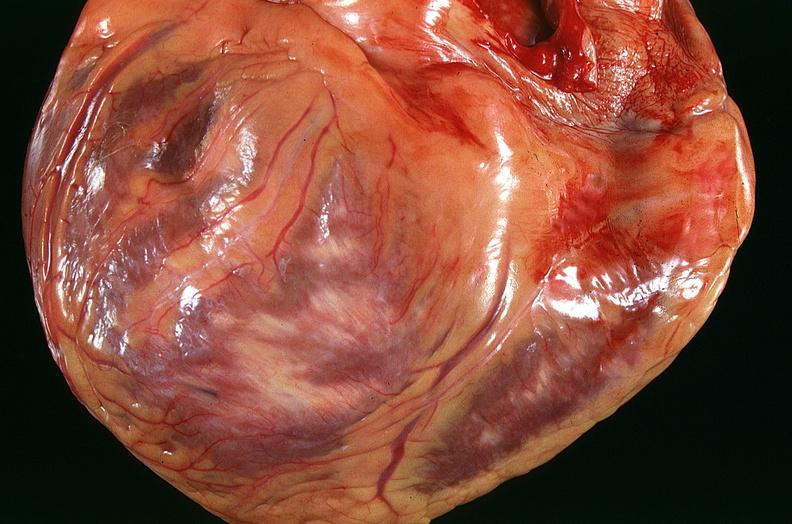how many vessel does this image show congestive heart failure, coronary artery disease?
Answer the question using a single word or phrase. Three 